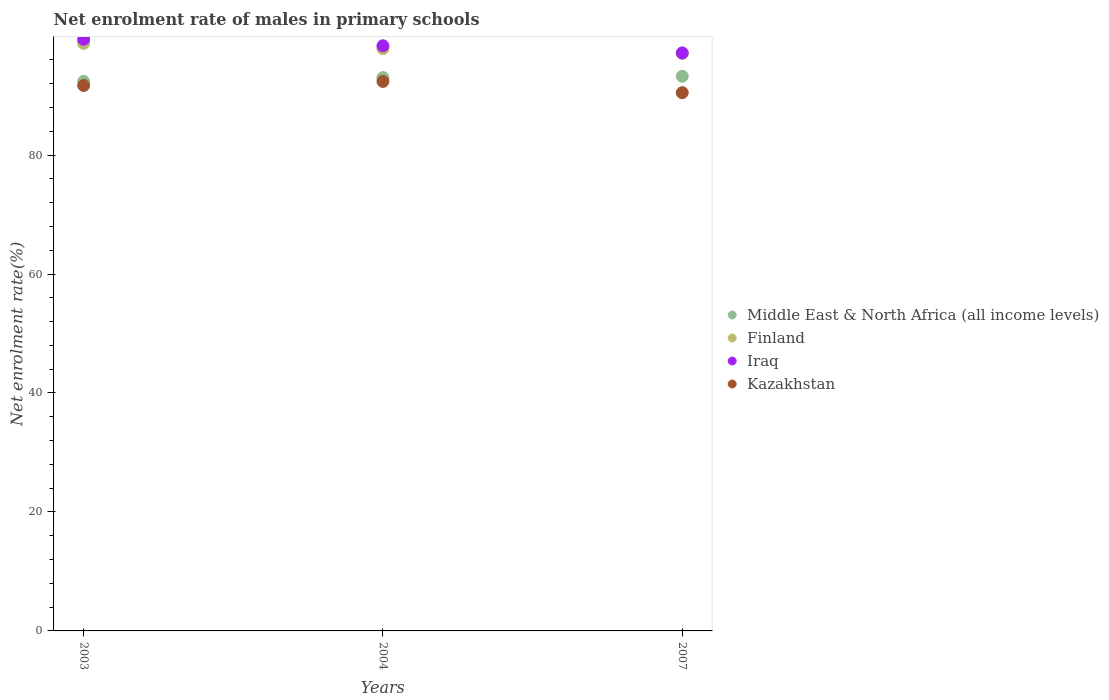What is the net enrolment rate of males in primary schools in Middle East & North Africa (all income levels) in 2003?
Offer a very short reply. 92.38. Across all years, what is the maximum net enrolment rate of males in primary schools in Kazakhstan?
Provide a short and direct response. 92.38. Across all years, what is the minimum net enrolment rate of males in primary schools in Iraq?
Your answer should be compact. 97.17. In which year was the net enrolment rate of males in primary schools in Kazakhstan minimum?
Your answer should be very brief. 2007. What is the total net enrolment rate of males in primary schools in Finland in the graph?
Make the answer very short. 293.74. What is the difference between the net enrolment rate of males in primary schools in Iraq in 2003 and that in 2004?
Your response must be concise. 1.1. What is the difference between the net enrolment rate of males in primary schools in Middle East & North Africa (all income levels) in 2004 and the net enrolment rate of males in primary schools in Iraq in 2007?
Your answer should be compact. -4.15. What is the average net enrolment rate of males in primary schools in Iraq per year?
Ensure brevity in your answer.  98.34. In the year 2003, what is the difference between the net enrolment rate of males in primary schools in Middle East & North Africa (all income levels) and net enrolment rate of males in primary schools in Iraq?
Give a very brief answer. -7.09. What is the ratio of the net enrolment rate of males in primary schools in Middle East & North Africa (all income levels) in 2003 to that in 2004?
Keep it short and to the point. 0.99. Is the net enrolment rate of males in primary schools in Kazakhstan in 2003 less than that in 2004?
Make the answer very short. Yes. What is the difference between the highest and the second highest net enrolment rate of males in primary schools in Finland?
Ensure brevity in your answer.  0.9. What is the difference between the highest and the lowest net enrolment rate of males in primary schools in Iraq?
Provide a succinct answer. 2.3. In how many years, is the net enrolment rate of males in primary schools in Finland greater than the average net enrolment rate of males in primary schools in Finland taken over all years?
Provide a succinct answer. 1. Is the net enrolment rate of males in primary schools in Kazakhstan strictly less than the net enrolment rate of males in primary schools in Middle East & North Africa (all income levels) over the years?
Keep it short and to the point. Yes. How many years are there in the graph?
Provide a succinct answer. 3. Does the graph contain grids?
Offer a terse response. No. How many legend labels are there?
Give a very brief answer. 4. How are the legend labels stacked?
Offer a very short reply. Vertical. What is the title of the graph?
Make the answer very short. Net enrolment rate of males in primary schools. Does "Lesotho" appear as one of the legend labels in the graph?
Your response must be concise. No. What is the label or title of the Y-axis?
Provide a succinct answer. Net enrolment rate(%). What is the Net enrolment rate(%) of Middle East & North Africa (all income levels) in 2003?
Your answer should be compact. 92.38. What is the Net enrolment rate(%) of Finland in 2003?
Ensure brevity in your answer.  98.78. What is the Net enrolment rate(%) in Iraq in 2003?
Keep it short and to the point. 99.47. What is the Net enrolment rate(%) in Kazakhstan in 2003?
Your answer should be compact. 91.69. What is the Net enrolment rate(%) in Middle East & North Africa (all income levels) in 2004?
Provide a short and direct response. 93.02. What is the Net enrolment rate(%) in Finland in 2004?
Your response must be concise. 97.88. What is the Net enrolment rate(%) of Iraq in 2004?
Give a very brief answer. 98.37. What is the Net enrolment rate(%) in Kazakhstan in 2004?
Your answer should be compact. 92.38. What is the Net enrolment rate(%) of Middle East & North Africa (all income levels) in 2007?
Keep it short and to the point. 93.24. What is the Net enrolment rate(%) of Finland in 2007?
Your response must be concise. 97.08. What is the Net enrolment rate(%) of Iraq in 2007?
Provide a succinct answer. 97.17. What is the Net enrolment rate(%) of Kazakhstan in 2007?
Keep it short and to the point. 90.48. Across all years, what is the maximum Net enrolment rate(%) in Middle East & North Africa (all income levels)?
Your answer should be very brief. 93.24. Across all years, what is the maximum Net enrolment rate(%) of Finland?
Your answer should be very brief. 98.78. Across all years, what is the maximum Net enrolment rate(%) of Iraq?
Offer a terse response. 99.47. Across all years, what is the maximum Net enrolment rate(%) of Kazakhstan?
Provide a short and direct response. 92.38. Across all years, what is the minimum Net enrolment rate(%) in Middle East & North Africa (all income levels)?
Offer a very short reply. 92.38. Across all years, what is the minimum Net enrolment rate(%) in Finland?
Your response must be concise. 97.08. Across all years, what is the minimum Net enrolment rate(%) in Iraq?
Your response must be concise. 97.17. Across all years, what is the minimum Net enrolment rate(%) of Kazakhstan?
Keep it short and to the point. 90.48. What is the total Net enrolment rate(%) of Middle East & North Africa (all income levels) in the graph?
Your answer should be compact. 278.64. What is the total Net enrolment rate(%) in Finland in the graph?
Provide a succinct answer. 293.74. What is the total Net enrolment rate(%) in Iraq in the graph?
Ensure brevity in your answer.  295.01. What is the total Net enrolment rate(%) of Kazakhstan in the graph?
Your answer should be compact. 274.55. What is the difference between the Net enrolment rate(%) in Middle East & North Africa (all income levels) in 2003 and that in 2004?
Your response must be concise. -0.64. What is the difference between the Net enrolment rate(%) of Finland in 2003 and that in 2004?
Provide a short and direct response. 0.9. What is the difference between the Net enrolment rate(%) in Iraq in 2003 and that in 2004?
Ensure brevity in your answer.  1.1. What is the difference between the Net enrolment rate(%) in Kazakhstan in 2003 and that in 2004?
Provide a succinct answer. -0.69. What is the difference between the Net enrolment rate(%) in Middle East & North Africa (all income levels) in 2003 and that in 2007?
Provide a short and direct response. -0.86. What is the difference between the Net enrolment rate(%) of Finland in 2003 and that in 2007?
Give a very brief answer. 1.7. What is the difference between the Net enrolment rate(%) of Iraq in 2003 and that in 2007?
Your response must be concise. 2.3. What is the difference between the Net enrolment rate(%) of Kazakhstan in 2003 and that in 2007?
Keep it short and to the point. 1.21. What is the difference between the Net enrolment rate(%) in Middle East & North Africa (all income levels) in 2004 and that in 2007?
Your answer should be very brief. -0.22. What is the difference between the Net enrolment rate(%) in Finland in 2004 and that in 2007?
Ensure brevity in your answer.  0.8. What is the difference between the Net enrolment rate(%) of Iraq in 2004 and that in 2007?
Ensure brevity in your answer.  1.2. What is the difference between the Net enrolment rate(%) of Kazakhstan in 2004 and that in 2007?
Your response must be concise. 1.89. What is the difference between the Net enrolment rate(%) of Middle East & North Africa (all income levels) in 2003 and the Net enrolment rate(%) of Finland in 2004?
Give a very brief answer. -5.5. What is the difference between the Net enrolment rate(%) in Middle East & North Africa (all income levels) in 2003 and the Net enrolment rate(%) in Iraq in 2004?
Offer a very short reply. -5.99. What is the difference between the Net enrolment rate(%) in Middle East & North Africa (all income levels) in 2003 and the Net enrolment rate(%) in Kazakhstan in 2004?
Make the answer very short. 0. What is the difference between the Net enrolment rate(%) of Finland in 2003 and the Net enrolment rate(%) of Iraq in 2004?
Offer a terse response. 0.41. What is the difference between the Net enrolment rate(%) in Finland in 2003 and the Net enrolment rate(%) in Kazakhstan in 2004?
Your response must be concise. 6.4. What is the difference between the Net enrolment rate(%) in Iraq in 2003 and the Net enrolment rate(%) in Kazakhstan in 2004?
Ensure brevity in your answer.  7.09. What is the difference between the Net enrolment rate(%) of Middle East & North Africa (all income levels) in 2003 and the Net enrolment rate(%) of Finland in 2007?
Offer a terse response. -4.7. What is the difference between the Net enrolment rate(%) in Middle East & North Africa (all income levels) in 2003 and the Net enrolment rate(%) in Iraq in 2007?
Your answer should be compact. -4.79. What is the difference between the Net enrolment rate(%) of Middle East & North Africa (all income levels) in 2003 and the Net enrolment rate(%) of Kazakhstan in 2007?
Keep it short and to the point. 1.89. What is the difference between the Net enrolment rate(%) of Finland in 2003 and the Net enrolment rate(%) of Iraq in 2007?
Your response must be concise. 1.61. What is the difference between the Net enrolment rate(%) in Finland in 2003 and the Net enrolment rate(%) in Kazakhstan in 2007?
Offer a terse response. 8.29. What is the difference between the Net enrolment rate(%) in Iraq in 2003 and the Net enrolment rate(%) in Kazakhstan in 2007?
Give a very brief answer. 8.98. What is the difference between the Net enrolment rate(%) of Middle East & North Africa (all income levels) in 2004 and the Net enrolment rate(%) of Finland in 2007?
Offer a very short reply. -4.06. What is the difference between the Net enrolment rate(%) of Middle East & North Africa (all income levels) in 2004 and the Net enrolment rate(%) of Iraq in 2007?
Provide a short and direct response. -4.15. What is the difference between the Net enrolment rate(%) in Middle East & North Africa (all income levels) in 2004 and the Net enrolment rate(%) in Kazakhstan in 2007?
Your answer should be very brief. 2.54. What is the difference between the Net enrolment rate(%) in Finland in 2004 and the Net enrolment rate(%) in Iraq in 2007?
Offer a terse response. 0.71. What is the difference between the Net enrolment rate(%) of Finland in 2004 and the Net enrolment rate(%) of Kazakhstan in 2007?
Provide a short and direct response. 7.39. What is the difference between the Net enrolment rate(%) of Iraq in 2004 and the Net enrolment rate(%) of Kazakhstan in 2007?
Offer a very short reply. 7.88. What is the average Net enrolment rate(%) in Middle East & North Africa (all income levels) per year?
Offer a terse response. 92.88. What is the average Net enrolment rate(%) in Finland per year?
Provide a succinct answer. 97.91. What is the average Net enrolment rate(%) of Iraq per year?
Your response must be concise. 98.34. What is the average Net enrolment rate(%) of Kazakhstan per year?
Offer a terse response. 91.52. In the year 2003, what is the difference between the Net enrolment rate(%) of Middle East & North Africa (all income levels) and Net enrolment rate(%) of Finland?
Ensure brevity in your answer.  -6.4. In the year 2003, what is the difference between the Net enrolment rate(%) in Middle East & North Africa (all income levels) and Net enrolment rate(%) in Iraq?
Provide a succinct answer. -7.09. In the year 2003, what is the difference between the Net enrolment rate(%) of Middle East & North Africa (all income levels) and Net enrolment rate(%) of Kazakhstan?
Ensure brevity in your answer.  0.69. In the year 2003, what is the difference between the Net enrolment rate(%) of Finland and Net enrolment rate(%) of Iraq?
Ensure brevity in your answer.  -0.69. In the year 2003, what is the difference between the Net enrolment rate(%) in Finland and Net enrolment rate(%) in Kazakhstan?
Offer a very short reply. 7.09. In the year 2003, what is the difference between the Net enrolment rate(%) in Iraq and Net enrolment rate(%) in Kazakhstan?
Make the answer very short. 7.78. In the year 2004, what is the difference between the Net enrolment rate(%) in Middle East & North Africa (all income levels) and Net enrolment rate(%) in Finland?
Provide a succinct answer. -4.86. In the year 2004, what is the difference between the Net enrolment rate(%) of Middle East & North Africa (all income levels) and Net enrolment rate(%) of Iraq?
Make the answer very short. -5.35. In the year 2004, what is the difference between the Net enrolment rate(%) of Middle East & North Africa (all income levels) and Net enrolment rate(%) of Kazakhstan?
Provide a succinct answer. 0.64. In the year 2004, what is the difference between the Net enrolment rate(%) of Finland and Net enrolment rate(%) of Iraq?
Keep it short and to the point. -0.49. In the year 2004, what is the difference between the Net enrolment rate(%) in Finland and Net enrolment rate(%) in Kazakhstan?
Provide a short and direct response. 5.5. In the year 2004, what is the difference between the Net enrolment rate(%) in Iraq and Net enrolment rate(%) in Kazakhstan?
Provide a succinct answer. 5.99. In the year 2007, what is the difference between the Net enrolment rate(%) in Middle East & North Africa (all income levels) and Net enrolment rate(%) in Finland?
Ensure brevity in your answer.  -3.84. In the year 2007, what is the difference between the Net enrolment rate(%) of Middle East & North Africa (all income levels) and Net enrolment rate(%) of Iraq?
Make the answer very short. -3.93. In the year 2007, what is the difference between the Net enrolment rate(%) in Middle East & North Africa (all income levels) and Net enrolment rate(%) in Kazakhstan?
Provide a succinct answer. 2.75. In the year 2007, what is the difference between the Net enrolment rate(%) of Finland and Net enrolment rate(%) of Iraq?
Provide a short and direct response. -0.09. In the year 2007, what is the difference between the Net enrolment rate(%) of Finland and Net enrolment rate(%) of Kazakhstan?
Provide a short and direct response. 6.6. In the year 2007, what is the difference between the Net enrolment rate(%) in Iraq and Net enrolment rate(%) in Kazakhstan?
Offer a very short reply. 6.69. What is the ratio of the Net enrolment rate(%) of Middle East & North Africa (all income levels) in 2003 to that in 2004?
Your answer should be compact. 0.99. What is the ratio of the Net enrolment rate(%) in Finland in 2003 to that in 2004?
Provide a succinct answer. 1.01. What is the ratio of the Net enrolment rate(%) in Iraq in 2003 to that in 2004?
Make the answer very short. 1.01. What is the ratio of the Net enrolment rate(%) of Kazakhstan in 2003 to that in 2004?
Keep it short and to the point. 0.99. What is the ratio of the Net enrolment rate(%) of Middle East & North Africa (all income levels) in 2003 to that in 2007?
Keep it short and to the point. 0.99. What is the ratio of the Net enrolment rate(%) of Finland in 2003 to that in 2007?
Ensure brevity in your answer.  1.02. What is the ratio of the Net enrolment rate(%) in Iraq in 2003 to that in 2007?
Offer a very short reply. 1.02. What is the ratio of the Net enrolment rate(%) in Kazakhstan in 2003 to that in 2007?
Your answer should be very brief. 1.01. What is the ratio of the Net enrolment rate(%) in Middle East & North Africa (all income levels) in 2004 to that in 2007?
Your response must be concise. 1. What is the ratio of the Net enrolment rate(%) in Finland in 2004 to that in 2007?
Provide a short and direct response. 1.01. What is the ratio of the Net enrolment rate(%) in Iraq in 2004 to that in 2007?
Offer a very short reply. 1.01. What is the ratio of the Net enrolment rate(%) of Kazakhstan in 2004 to that in 2007?
Offer a terse response. 1.02. What is the difference between the highest and the second highest Net enrolment rate(%) of Middle East & North Africa (all income levels)?
Offer a very short reply. 0.22. What is the difference between the highest and the second highest Net enrolment rate(%) of Finland?
Your answer should be compact. 0.9. What is the difference between the highest and the second highest Net enrolment rate(%) of Iraq?
Your response must be concise. 1.1. What is the difference between the highest and the second highest Net enrolment rate(%) in Kazakhstan?
Provide a succinct answer. 0.69. What is the difference between the highest and the lowest Net enrolment rate(%) in Middle East & North Africa (all income levels)?
Provide a short and direct response. 0.86. What is the difference between the highest and the lowest Net enrolment rate(%) of Finland?
Provide a short and direct response. 1.7. What is the difference between the highest and the lowest Net enrolment rate(%) of Iraq?
Offer a very short reply. 2.3. What is the difference between the highest and the lowest Net enrolment rate(%) in Kazakhstan?
Ensure brevity in your answer.  1.89. 